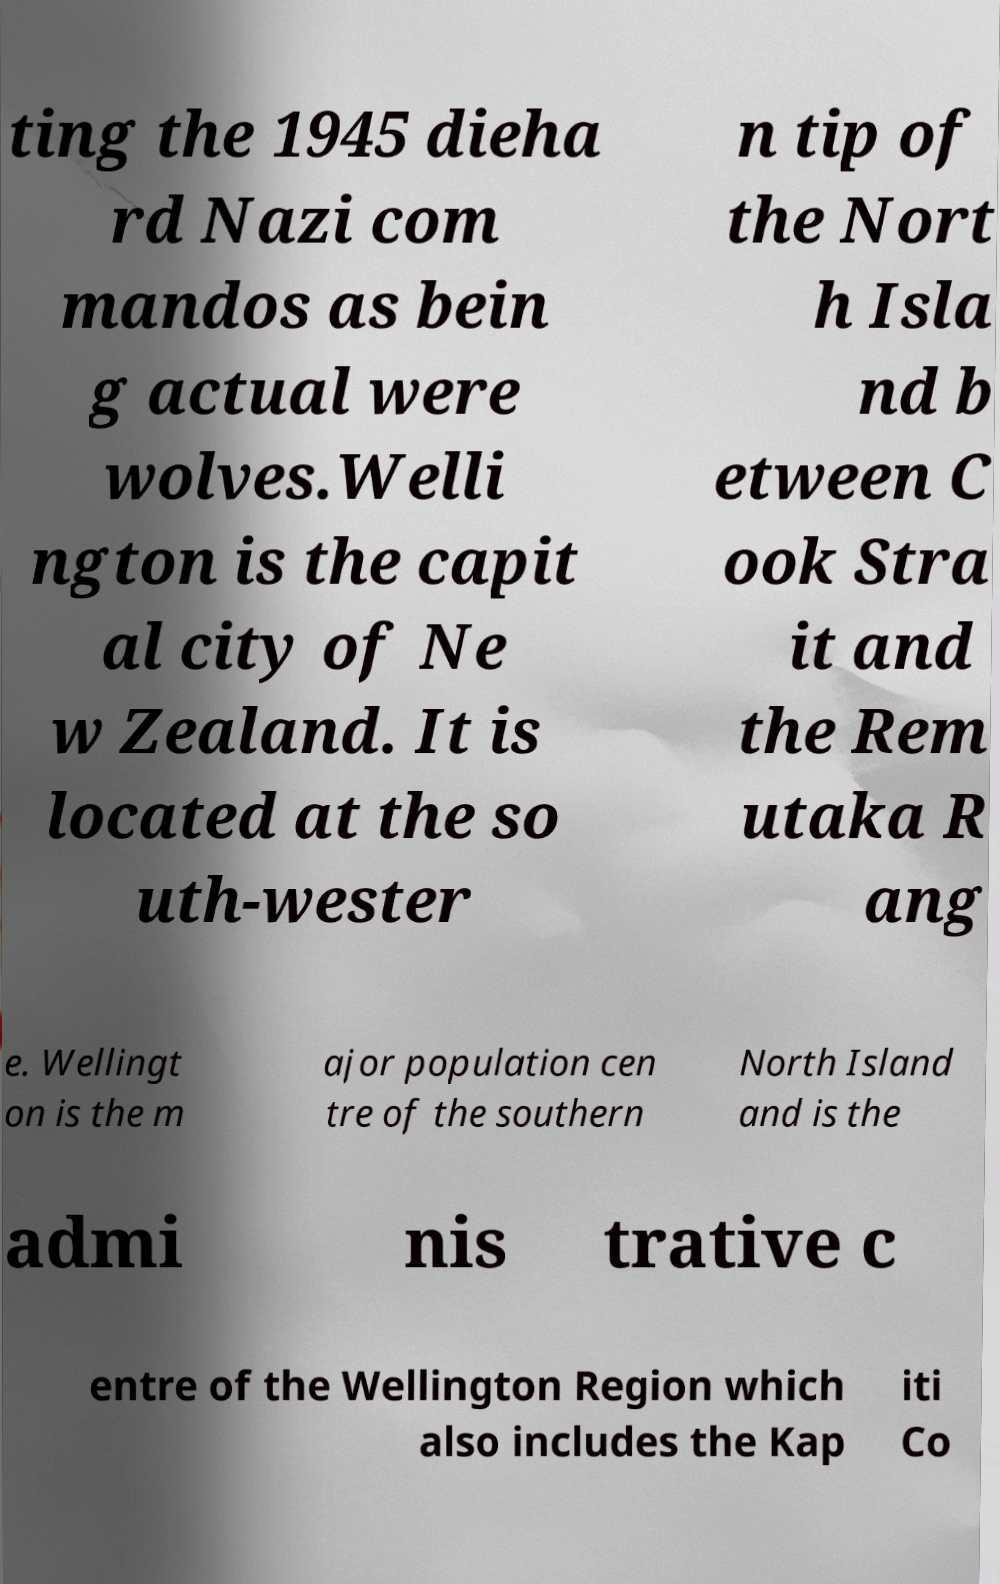Please identify and transcribe the text found in this image. ting the 1945 dieha rd Nazi com mandos as bein g actual were wolves.Welli ngton is the capit al city of Ne w Zealand. It is located at the so uth-wester n tip of the Nort h Isla nd b etween C ook Stra it and the Rem utaka R ang e. Wellingt on is the m ajor population cen tre of the southern North Island and is the admi nis trative c entre of the Wellington Region which also includes the Kap iti Co 